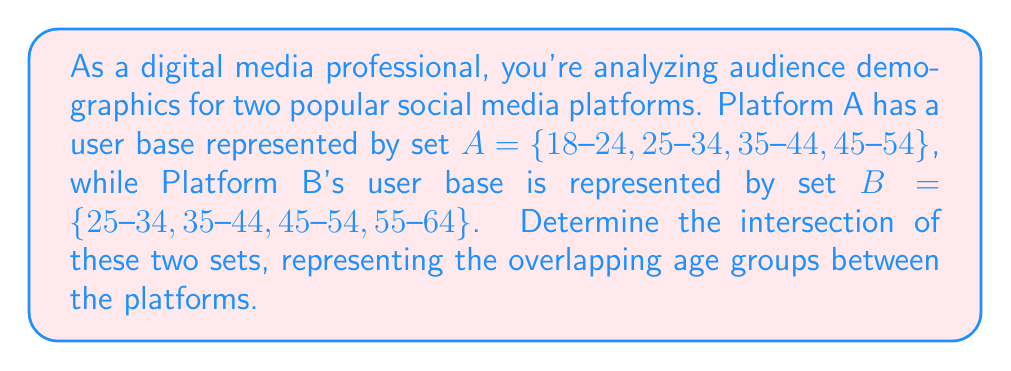Provide a solution to this math problem. To solve this problem, we need to identify the elements that are common to both sets. Let's break it down step-by-step:

1. We have two sets:
   $A = \{18-24, 25-34, 35-44, 45-54\}$
   $B = \{25-34, 35-44, 45-54, 55-64\}$

2. The intersection of two sets is defined as the set of elements that are present in both sets. We denote this as $A \cap B$.

3. Let's compare each element:
   - 18-24: Only in set A
   - 25-34: In both sets A and B
   - 35-44: In both sets A and B
   - 45-54: In both sets A and B
   - 55-64: Only in set B

4. The elements that appear in both sets are: 25-34, 35-44, and 45-54.

5. Therefore, the intersection of sets A and B is:
   $A \cap B = \{25-34, 35-44, 45-54\}$

This result represents the age groups that are common to both social media platforms, which is valuable information for targeting cross-platform marketing campaigns or understanding the core demographic shared by both platforms.
Answer: $A \cap B = \{25-34, 35-44, 45-54\}$ 